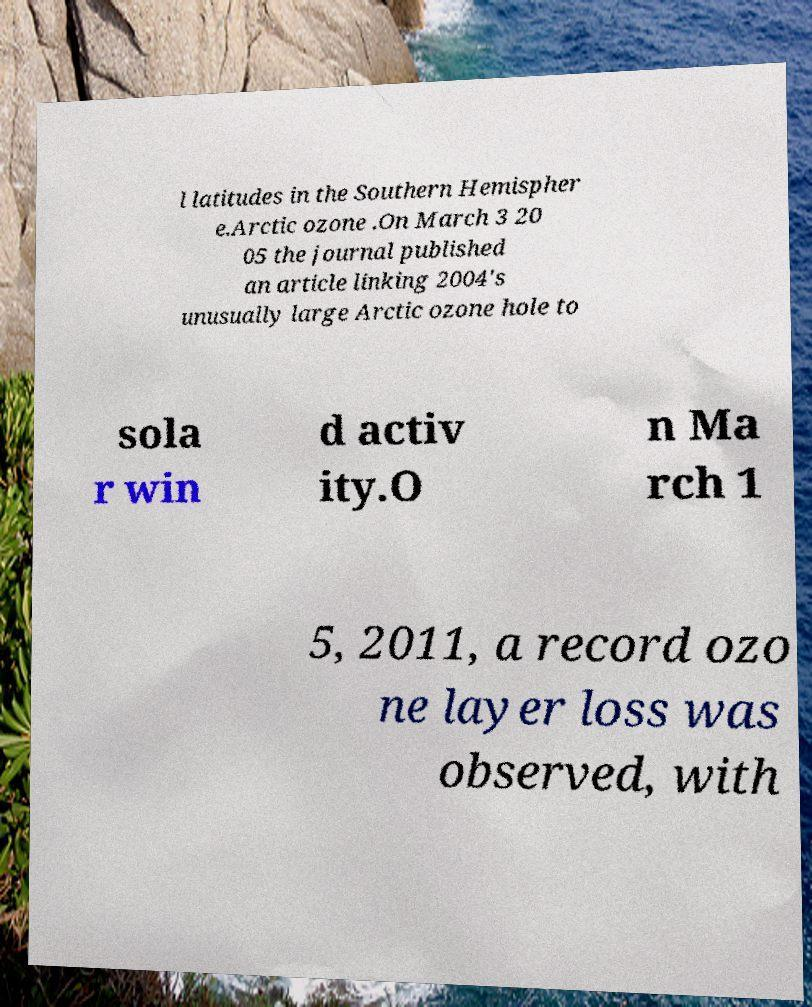For documentation purposes, I need the text within this image transcribed. Could you provide that? l latitudes in the Southern Hemispher e.Arctic ozone .On March 3 20 05 the journal published an article linking 2004's unusually large Arctic ozone hole to sola r win d activ ity.O n Ma rch 1 5, 2011, a record ozo ne layer loss was observed, with 